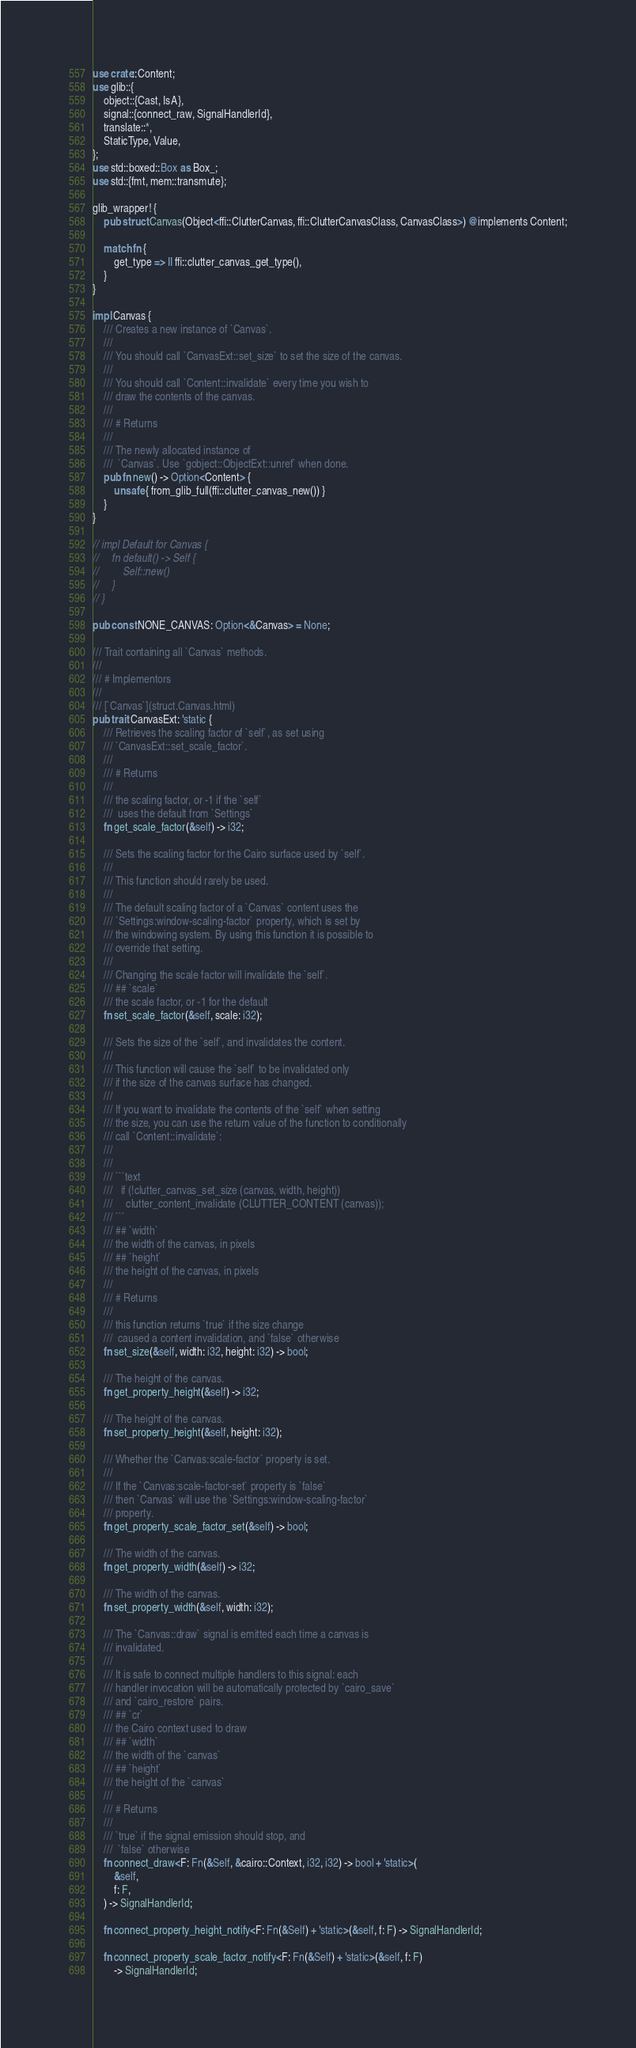<code> <loc_0><loc_0><loc_500><loc_500><_Rust_>use crate::Content;
use glib::{
    object::{Cast, IsA},
    signal::{connect_raw, SignalHandlerId},
    translate::*,
    StaticType, Value,
};
use std::boxed::Box as Box_;
use std::{fmt, mem::transmute};

glib_wrapper! {
    pub struct Canvas(Object<ffi::ClutterCanvas, ffi::ClutterCanvasClass, CanvasClass>) @implements Content;

    match fn {
        get_type => || ffi::clutter_canvas_get_type(),
    }
}

impl Canvas {
    /// Creates a new instance of `Canvas`.
    ///
    /// You should call `CanvasExt::set_size` to set the size of the canvas.
    ///
    /// You should call `Content::invalidate` every time you wish to
    /// draw the contents of the canvas.
    ///
    /// # Returns
    ///
    /// The newly allocated instance of
    ///  `Canvas`. Use `gobject::ObjectExt::unref` when done.
    pub fn new() -> Option<Content> {
        unsafe { from_glib_full(ffi::clutter_canvas_new()) }
    }
}

// impl Default for Canvas {
//     fn default() -> Self {
//         Self::new()
//     }
// }

pub const NONE_CANVAS: Option<&Canvas> = None;

/// Trait containing all `Canvas` methods.
///
/// # Implementors
///
/// [`Canvas`](struct.Canvas.html)
pub trait CanvasExt: 'static {
    /// Retrieves the scaling factor of `self`, as set using
    /// `CanvasExt::set_scale_factor`.
    ///
    /// # Returns
    ///
    /// the scaling factor, or -1 if the `self`
    ///  uses the default from `Settings`
    fn get_scale_factor(&self) -> i32;

    /// Sets the scaling factor for the Cairo surface used by `self`.
    ///
    /// This function should rarely be used.
    ///
    /// The default scaling factor of a `Canvas` content uses the
    /// `Settings:window-scaling-factor` property, which is set by
    /// the windowing system. By using this function it is possible to
    /// override that setting.
    ///
    /// Changing the scale factor will invalidate the `self`.
    /// ## `scale`
    /// the scale factor, or -1 for the default
    fn set_scale_factor(&self, scale: i32);

    /// Sets the size of the `self`, and invalidates the content.
    ///
    /// This function will cause the `self` to be invalidated only
    /// if the size of the canvas surface has changed.
    ///
    /// If you want to invalidate the contents of the `self` when setting
    /// the size, you can use the return value of the function to conditionally
    /// call `Content::invalidate`:
    ///
    ///
    /// ```text
    ///   if (!clutter_canvas_set_size (canvas, width, height))
    ///     clutter_content_invalidate (CLUTTER_CONTENT (canvas));
    /// ```
    /// ## `width`
    /// the width of the canvas, in pixels
    /// ## `height`
    /// the height of the canvas, in pixels
    ///
    /// # Returns
    ///
    /// this function returns `true` if the size change
    ///  caused a content invalidation, and `false` otherwise
    fn set_size(&self, width: i32, height: i32) -> bool;

    /// The height of the canvas.
    fn get_property_height(&self) -> i32;

    /// The height of the canvas.
    fn set_property_height(&self, height: i32);

    /// Whether the `Canvas:scale-factor` property is set.
    ///
    /// If the `Canvas:scale-factor-set` property is `false`
    /// then `Canvas` will use the `Settings:window-scaling-factor`
    /// property.
    fn get_property_scale_factor_set(&self) -> bool;

    /// The width of the canvas.
    fn get_property_width(&self) -> i32;

    /// The width of the canvas.
    fn set_property_width(&self, width: i32);

    /// The `Canvas::draw` signal is emitted each time a canvas is
    /// invalidated.
    ///
    /// It is safe to connect multiple handlers to this signal: each
    /// handler invocation will be automatically protected by `cairo_save`
    /// and `cairo_restore` pairs.
    /// ## `cr`
    /// the Cairo context used to draw
    /// ## `width`
    /// the width of the `canvas`
    /// ## `height`
    /// the height of the `canvas`
    ///
    /// # Returns
    ///
    /// `true` if the signal emission should stop, and
    ///  `false` otherwise
    fn connect_draw<F: Fn(&Self, &cairo::Context, i32, i32) -> bool + 'static>(
        &self,
        f: F,
    ) -> SignalHandlerId;

    fn connect_property_height_notify<F: Fn(&Self) + 'static>(&self, f: F) -> SignalHandlerId;

    fn connect_property_scale_factor_notify<F: Fn(&Self) + 'static>(&self, f: F)
        -> SignalHandlerId;
</code> 